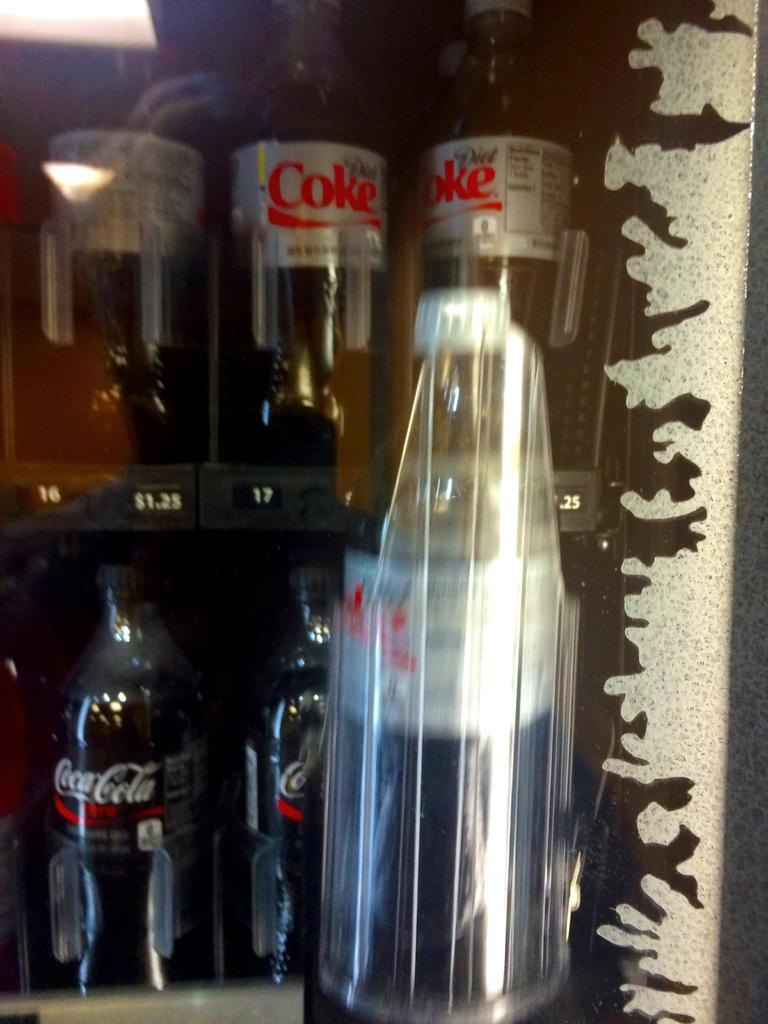Could you give a brief overview of what you see in this image? This picture is mainly highlighted with preservative drinking bottles. 